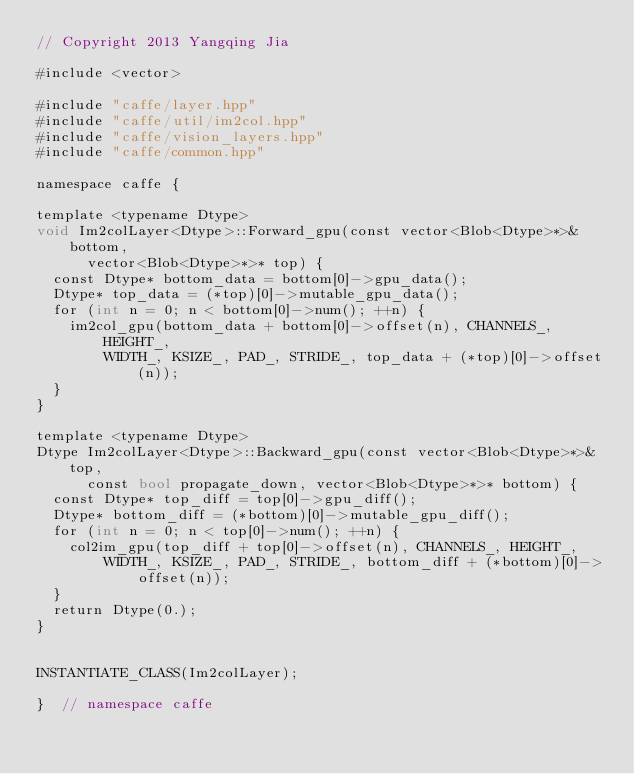<code> <loc_0><loc_0><loc_500><loc_500><_Cuda_>// Copyright 2013 Yangqing Jia

#include <vector>

#include "caffe/layer.hpp"
#include "caffe/util/im2col.hpp"
#include "caffe/vision_layers.hpp"
#include "caffe/common.hpp"

namespace caffe {

template <typename Dtype>
void Im2colLayer<Dtype>::Forward_gpu(const vector<Blob<Dtype>*>& bottom,
      vector<Blob<Dtype>*>* top) {
  const Dtype* bottom_data = bottom[0]->gpu_data();
  Dtype* top_data = (*top)[0]->mutable_gpu_data();
  for (int n = 0; n < bottom[0]->num(); ++n) {
    im2col_gpu(bottom_data + bottom[0]->offset(n), CHANNELS_, HEIGHT_,
        WIDTH_, KSIZE_, PAD_, STRIDE_, top_data + (*top)[0]->offset(n));
  }
}

template <typename Dtype>
Dtype Im2colLayer<Dtype>::Backward_gpu(const vector<Blob<Dtype>*>& top,
      const bool propagate_down, vector<Blob<Dtype>*>* bottom) {
  const Dtype* top_diff = top[0]->gpu_diff();
  Dtype* bottom_diff = (*bottom)[0]->mutable_gpu_diff();
  for (int n = 0; n < top[0]->num(); ++n) {
    col2im_gpu(top_diff + top[0]->offset(n), CHANNELS_, HEIGHT_,
        WIDTH_, KSIZE_, PAD_, STRIDE_, bottom_diff + (*bottom)[0]->offset(n));
  }
  return Dtype(0.);
}


INSTANTIATE_CLASS(Im2colLayer);

}  // namespace caffe
</code> 